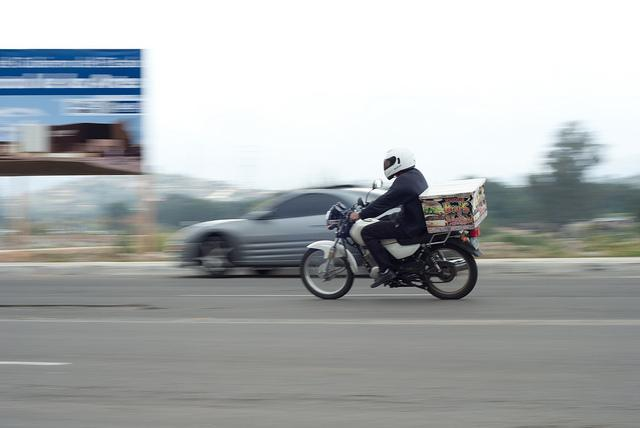How do motorcyclists carry gear? back side 